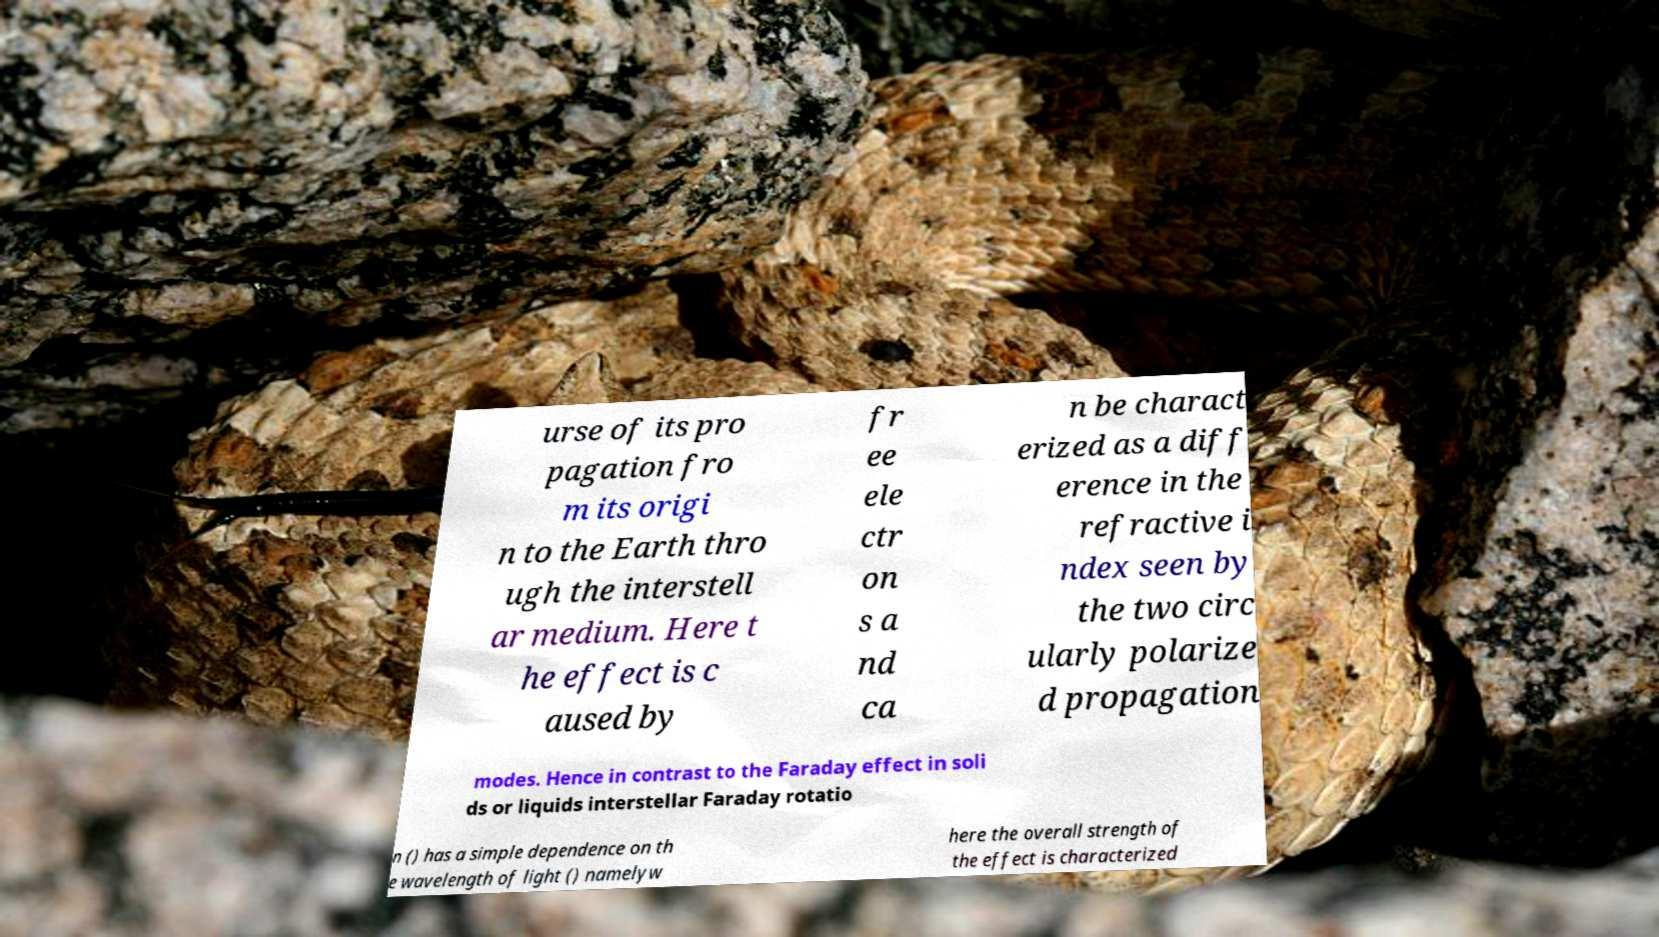Could you extract and type out the text from this image? urse of its pro pagation fro m its origi n to the Earth thro ugh the interstell ar medium. Here t he effect is c aused by fr ee ele ctr on s a nd ca n be charact erized as a diff erence in the refractive i ndex seen by the two circ ularly polarize d propagation modes. Hence in contrast to the Faraday effect in soli ds or liquids interstellar Faraday rotatio n () has a simple dependence on th e wavelength of light () namelyw here the overall strength of the effect is characterized 